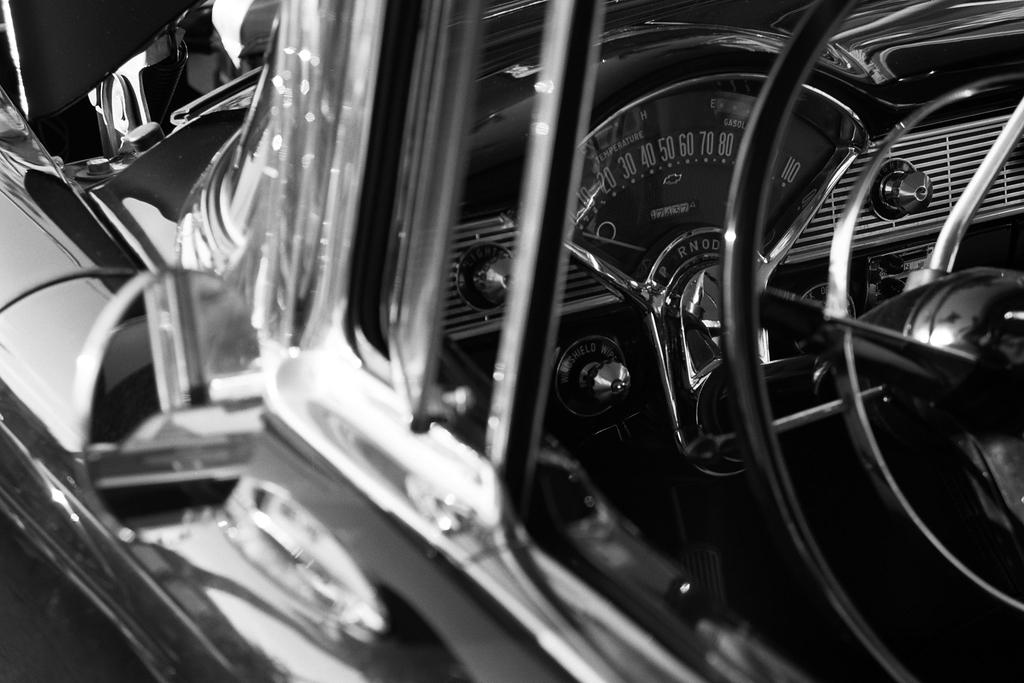What type of vehicle is in the image? The type of vehicle cannot be determined from the provided facts. What features are present in the vehicle? The vehicle has a steering wheel, a speedometer, side mirrors, and an engine. What is the color scheme of the image? The image is black and white. How many signs are visible in the image? There are no signs present in the image; it only features a vehicle with various features. What type of linen is draped over the vehicle in the image? There is no linen present in the image; it only features a vehicle with various features. 